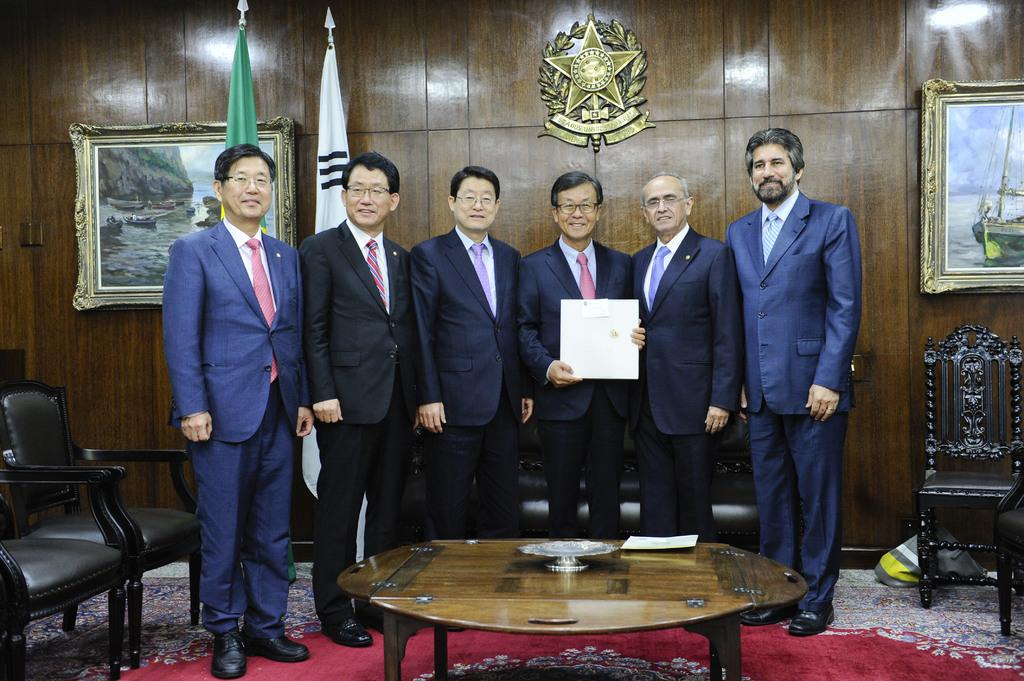How many people are in the image? There is a group of people in the image, but the exact number is not specified. What are the people in the image doing? The people are standing in the image. What are the people holding in their hands? The people are holding an object in their hands. What can be seen in the background of the image? There is an image in the background of the image. What type of receipt can be seen in the image? There is no receipt present in the image. How many squirrels are visible in the image? There are no squirrels visible in the image. 